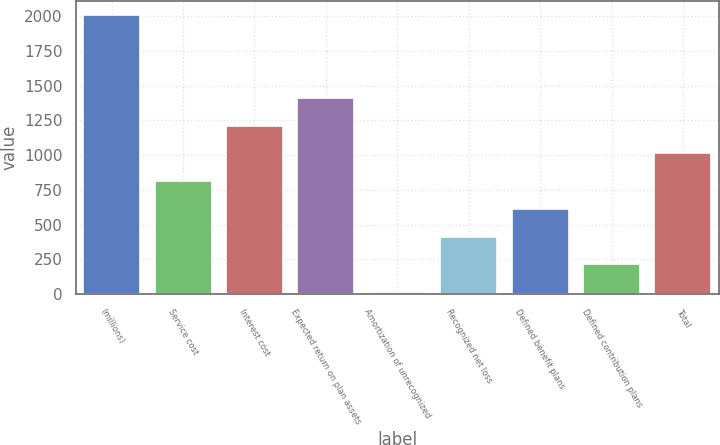<chart> <loc_0><loc_0><loc_500><loc_500><bar_chart><fcel>(millions)<fcel>Service cost<fcel>Interest cost<fcel>Expected return on plan assets<fcel>Amortization of unrecognized<fcel>Recognized net loss<fcel>Defined benefit plans<fcel>Defined contribution plans<fcel>Total<nl><fcel>2010<fcel>812.4<fcel>1211.6<fcel>1411.2<fcel>14<fcel>413.2<fcel>612.8<fcel>213.6<fcel>1012<nl></chart> 